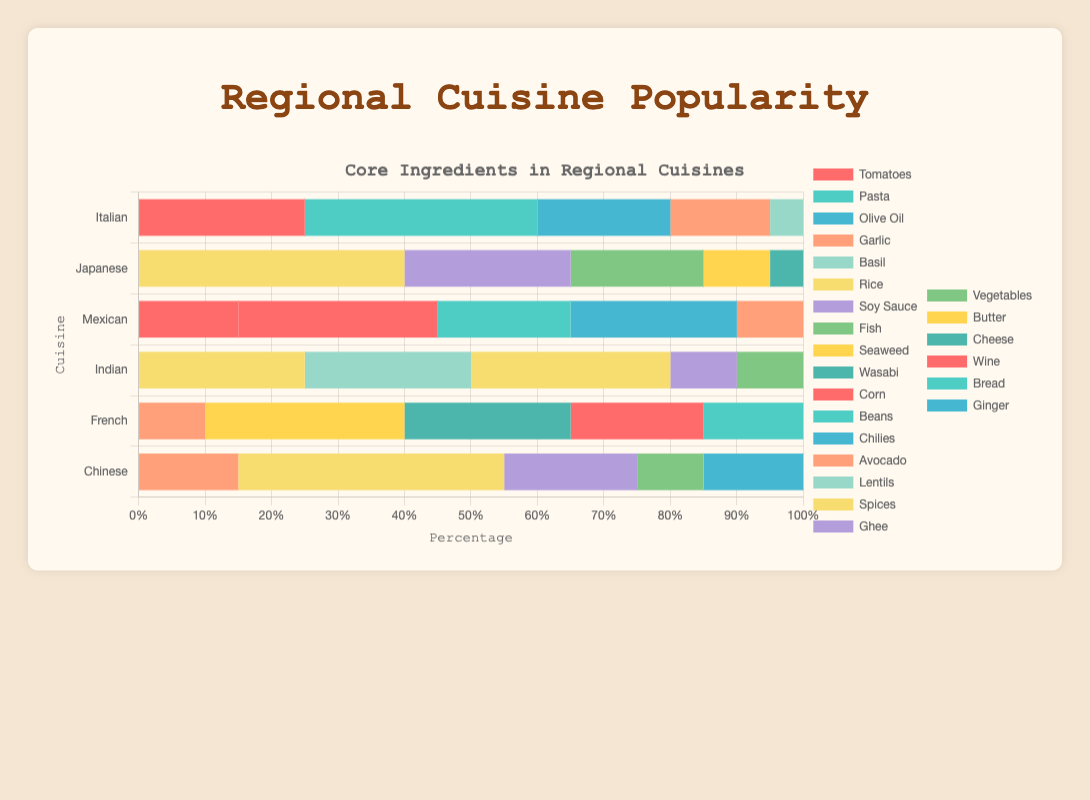What is the most frequently used ingredient in Italian cuisine? By looking at the Italian section of the horizontal stacked bar chart, we can see that Pasta occupies the largest portion compared to Tomatoes, Olive Oil, Garlic, and Basil.
Answer: Pasta Which cuisine makes the most extensive use of Rice? Comparing the lengths of the Rice segments across all regional cuisines (Japanese, Indian, Chinese), it is seen that both Japanese and Chinese use Rice extensively, each with a 40% share.
Answer: Japanese and Chinese Between Italian and Mexican cuisines, which one uses more Tomatoes? Observing the lengths of the Tomato segments for both Italian and Mexican cuisines, it is evident that Italian cuisine uses more Tomatoes than Mexican cuisine.
Answer: Italian What is the proportional difference in the use of Garlic between French and Chinese cuisines? French cuisine uses Garlic at 10%, while Chinese cuisine uses it at 15%. The difference in proportion is 15% - 10%.
Answer: 5% Considering French cuisine, how much more common is Butter compared to Bread? The Butter segment is at 30%, and Bread is at 15%. To find the difference, we subtract 15 from 30.
Answer: 15% In Japanese cuisine, by how much does the use of Soy Sauce exceed that of Wasabi? The Soy Sauce portion is 25%, and the Wasabi portion is 5%. The difference is calculated by subtracting 5 from 25.
Answer: 20% Which ingredient is unique to Japanese cuisine and what is its percentage? Observing the data, Wasabi is found only in Japanese cuisine and is represented by a unique color segment in that bar. The percentage is 5%.
Answer: Wasabi, 5% Which cuisine has the most even distribution of its top five ingredients? By visual inspection, Indian cuisine appears to have a more even distribution among its top five ingredients compared to the others, as the bar sections for each ingredient are relatively comparable in size.
Answer: Indian How does the use of Beans in Mexican cuisine compare to the use of Cheese in French cuisine? Looking at the bar segments, Beans in Mexican cuisine account for 20%, while Cheese in French cuisine accounts for 25%. Thus, Cheese is used more frequently than Beans in these respective cuisines.
Answer: Cheese > Beans 